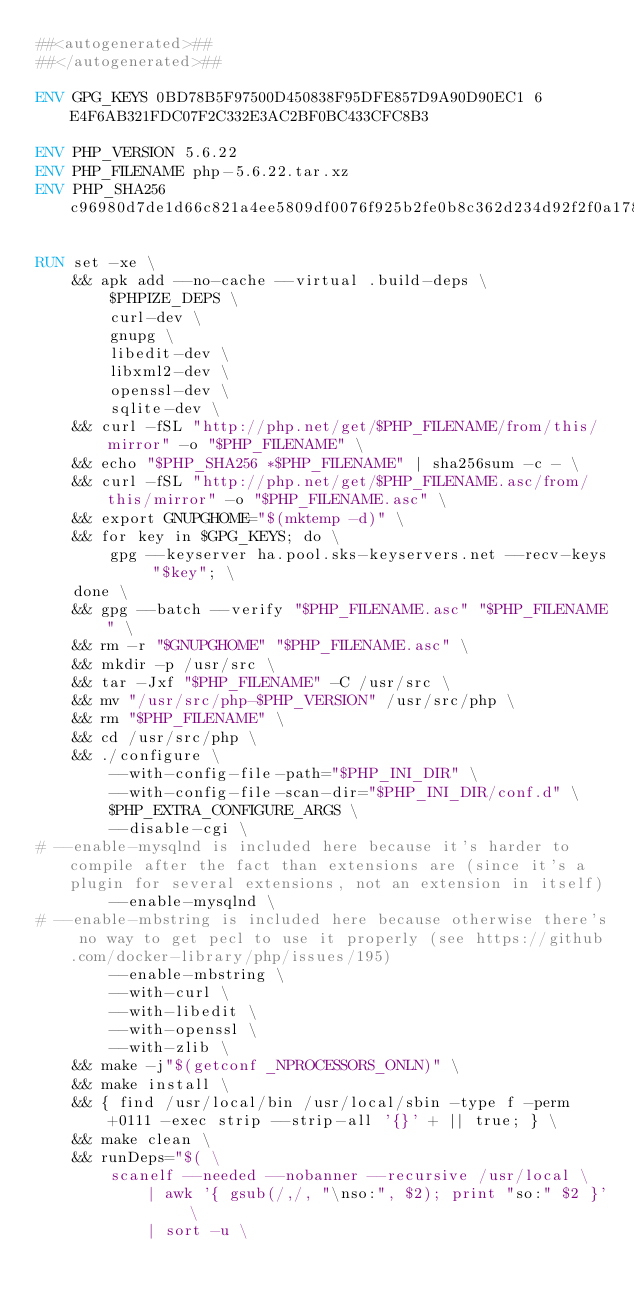Convert code to text. <code><loc_0><loc_0><loc_500><loc_500><_Dockerfile_>##<autogenerated>##
##</autogenerated>##

ENV GPG_KEYS 0BD78B5F97500D450838F95DFE857D9A90D90EC1 6E4F6AB321FDC07F2C332E3AC2BF0BC433CFC8B3

ENV PHP_VERSION 5.6.22
ENV PHP_FILENAME php-5.6.22.tar.xz
ENV PHP_SHA256 c96980d7de1d66c821a4ee5809df0076f925b2fe0b8c362d234d92f2f0a178e2

RUN set -xe \
	&& apk add --no-cache --virtual .build-deps \
		$PHPIZE_DEPS \
		curl-dev \
		gnupg \
		libedit-dev \
		libxml2-dev \
		openssl-dev \
		sqlite-dev \
	&& curl -fSL "http://php.net/get/$PHP_FILENAME/from/this/mirror" -o "$PHP_FILENAME" \
	&& echo "$PHP_SHA256 *$PHP_FILENAME" | sha256sum -c - \
	&& curl -fSL "http://php.net/get/$PHP_FILENAME.asc/from/this/mirror" -o "$PHP_FILENAME.asc" \
	&& export GNUPGHOME="$(mktemp -d)" \
	&& for key in $GPG_KEYS; do \
		gpg --keyserver ha.pool.sks-keyservers.net --recv-keys "$key"; \
	done \
	&& gpg --batch --verify "$PHP_FILENAME.asc" "$PHP_FILENAME" \
	&& rm -r "$GNUPGHOME" "$PHP_FILENAME.asc" \
	&& mkdir -p /usr/src \
	&& tar -Jxf "$PHP_FILENAME" -C /usr/src \
	&& mv "/usr/src/php-$PHP_VERSION" /usr/src/php \
	&& rm "$PHP_FILENAME" \
	&& cd /usr/src/php \
	&& ./configure \
		--with-config-file-path="$PHP_INI_DIR" \
		--with-config-file-scan-dir="$PHP_INI_DIR/conf.d" \
		$PHP_EXTRA_CONFIGURE_ARGS \
		--disable-cgi \
# --enable-mysqlnd is included here because it's harder to compile after the fact than extensions are (since it's a plugin for several extensions, not an extension in itself)
		--enable-mysqlnd \
# --enable-mbstring is included here because otherwise there's no way to get pecl to use it properly (see https://github.com/docker-library/php/issues/195)
		--enable-mbstring \
		--with-curl \
		--with-libedit \
		--with-openssl \
		--with-zlib \
	&& make -j"$(getconf _NPROCESSORS_ONLN)" \
	&& make install \
	&& { find /usr/local/bin /usr/local/sbin -type f -perm +0111 -exec strip --strip-all '{}' + || true; } \
	&& make clean \
	&& runDeps="$( \
		scanelf --needed --nobanner --recursive /usr/local \
			| awk '{ gsub(/,/, "\nso:", $2); print "so:" $2 }' \
			| sort -u \</code> 